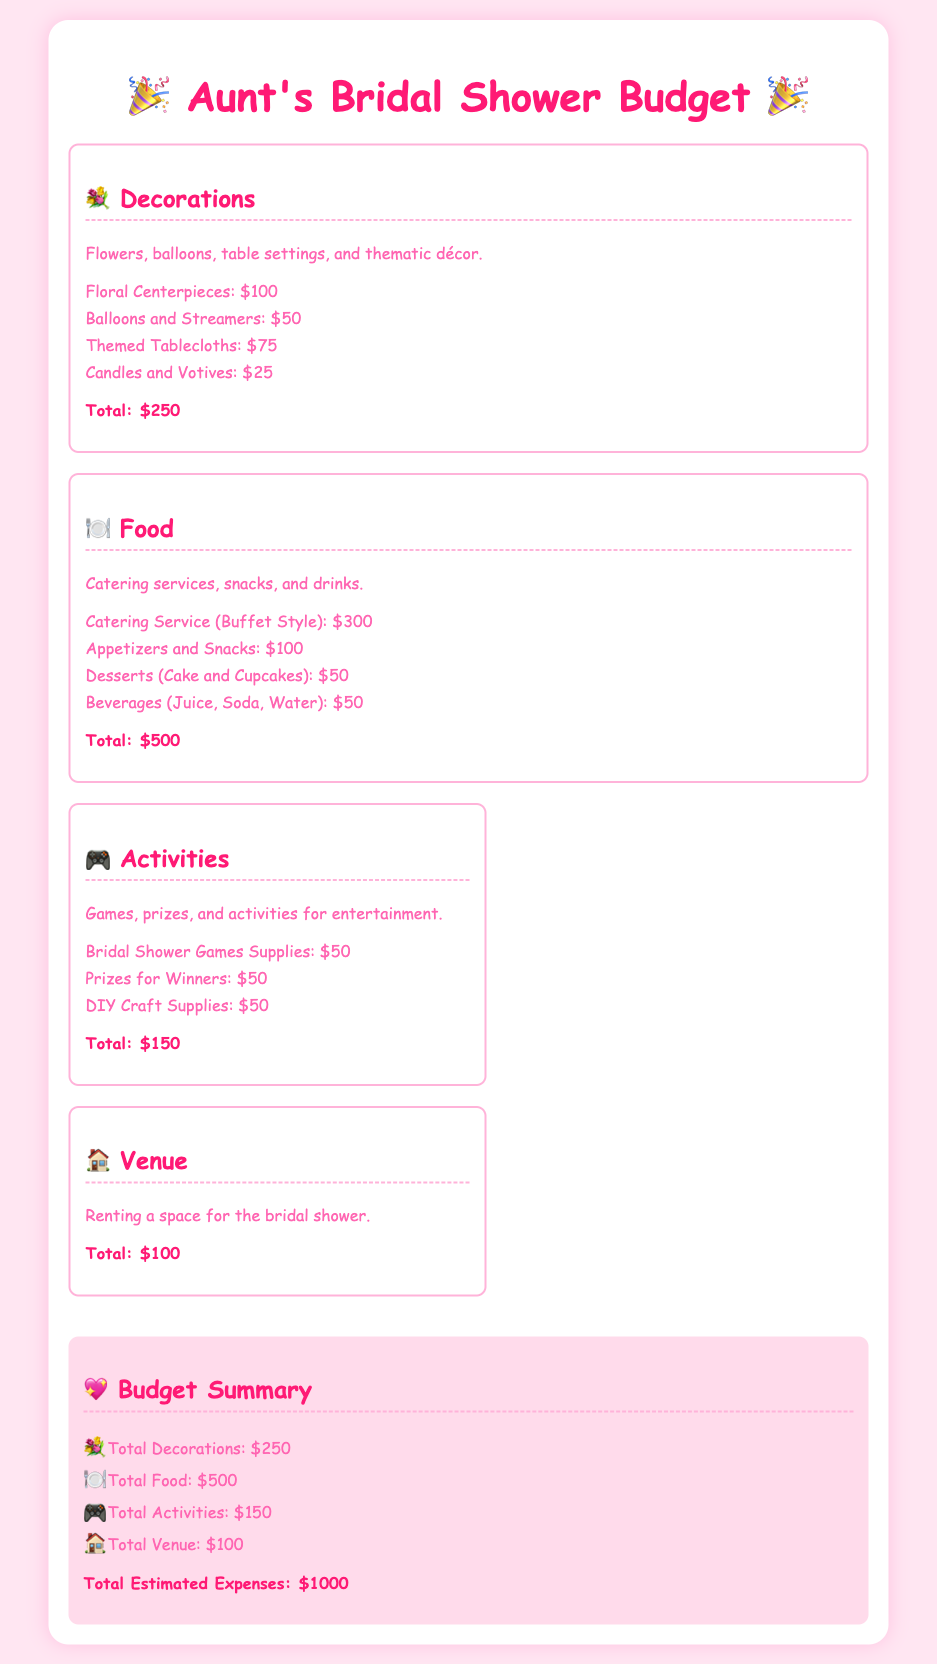What is the total budget for decorations? The total for decorations is listed at the end of the decorations section in the document.
Answer: $250 How much is allocated for food? The food total is found in the food section of the document, summing up all food-related expenses.
Answer: $500 What is included in the activities costs? The activities section lists specific items that contribute to the total costs, making it relatable to activities planned for the bridal shower.
Answer: Bridal Shower Games Supplies, Prizes for Winners, DIY Craft Supplies What is the total venue cost? The venue cost is a separate section and constitutes the renting expenses for the bridal shower space.
Answer: $100 What is the total estimated expense for the bridal shower? The document provides a summary that combines all costs, including decorations, food, activities, and venue.
Answer: $1000 Which section has the highest estimated expenses? To find this, one compares the totals of decorations, food, activities, and venue.
Answer: Food How much is budgeted for prizes for the activities? The specific item for prizes in the activities section provides the exact cost.
Answer: $50 What is the purpose of the document? The document serves to outline the expenses related to a bridal shower, providing a structured budget overview.
Answer: Overview of budget for bridal shower expenses What type of expenses are included under food? The food section lists specific expense types that fall under the food category for the bridal shower.
Answer: Catering Service, Appetizers, Desserts, Beverages 